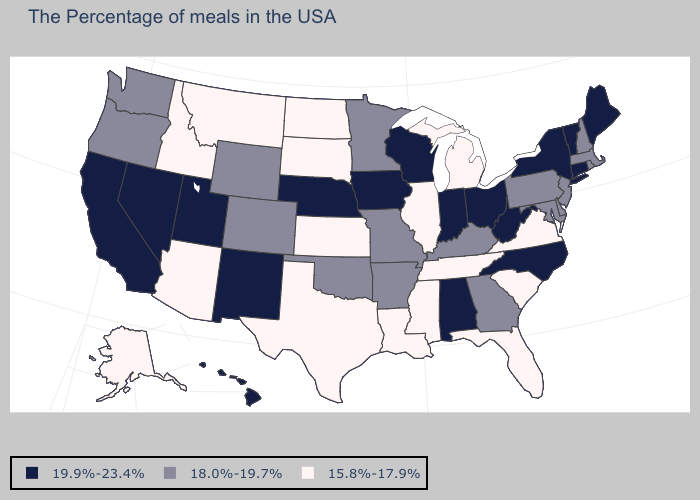Among the states that border Idaho , does Washington have the lowest value?
Keep it brief. No. Which states have the highest value in the USA?
Short answer required. Maine, Vermont, Connecticut, New York, North Carolina, West Virginia, Ohio, Indiana, Alabama, Wisconsin, Iowa, Nebraska, New Mexico, Utah, Nevada, California, Hawaii. Among the states that border Indiana , does Ohio have the highest value?
Write a very short answer. Yes. Is the legend a continuous bar?
Give a very brief answer. No. Name the states that have a value in the range 18.0%-19.7%?
Be succinct. Massachusetts, Rhode Island, New Hampshire, New Jersey, Delaware, Maryland, Pennsylvania, Georgia, Kentucky, Missouri, Arkansas, Minnesota, Oklahoma, Wyoming, Colorado, Washington, Oregon. What is the highest value in states that border Minnesota?
Concise answer only. 19.9%-23.4%. What is the lowest value in the USA?
Keep it brief. 15.8%-17.9%. Among the states that border Iowa , does Wisconsin have the highest value?
Be succinct. Yes. Name the states that have a value in the range 15.8%-17.9%?
Answer briefly. Virginia, South Carolina, Florida, Michigan, Tennessee, Illinois, Mississippi, Louisiana, Kansas, Texas, South Dakota, North Dakota, Montana, Arizona, Idaho, Alaska. Which states hav the highest value in the South?
Be succinct. North Carolina, West Virginia, Alabama. Does the first symbol in the legend represent the smallest category?
Give a very brief answer. No. Which states have the lowest value in the USA?
Answer briefly. Virginia, South Carolina, Florida, Michigan, Tennessee, Illinois, Mississippi, Louisiana, Kansas, Texas, South Dakota, North Dakota, Montana, Arizona, Idaho, Alaska. What is the value of Kentucky?
Keep it brief. 18.0%-19.7%. What is the value of New Mexico?
Give a very brief answer. 19.9%-23.4%. Which states hav the highest value in the South?
Answer briefly. North Carolina, West Virginia, Alabama. 